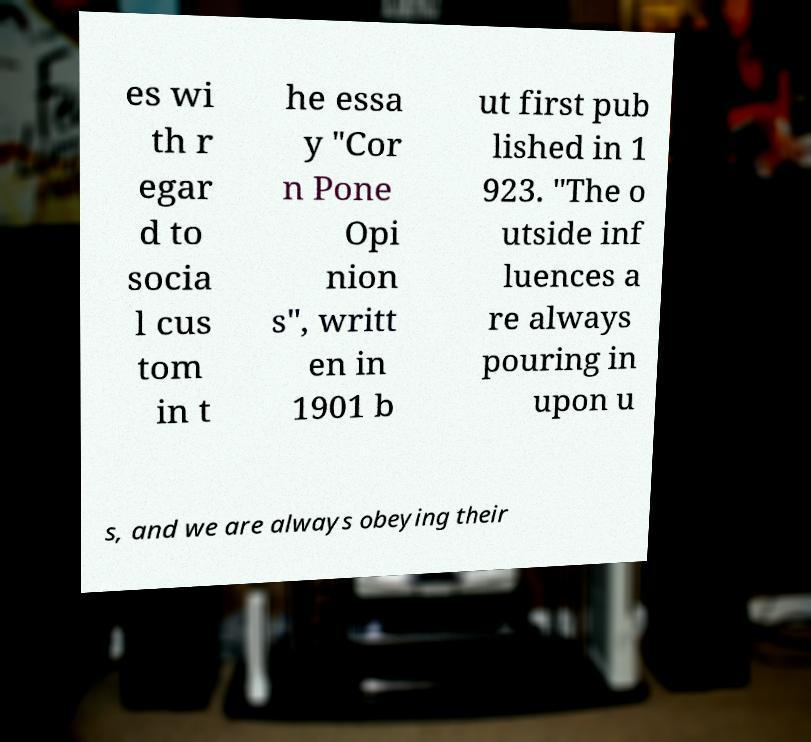Please read and relay the text visible in this image. What does it say? es wi th r egar d to socia l cus tom in t he essa y "Cor n Pone Opi nion s", writt en in 1901 b ut first pub lished in 1 923. "The o utside inf luences a re always pouring in upon u s, and we are always obeying their 